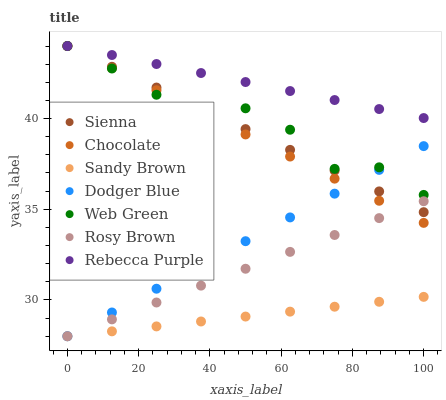Does Sandy Brown have the minimum area under the curve?
Answer yes or no. Yes. Does Rebecca Purple have the maximum area under the curve?
Answer yes or no. Yes. Does Web Green have the minimum area under the curve?
Answer yes or no. No. Does Web Green have the maximum area under the curve?
Answer yes or no. No. Is Rosy Brown the smoothest?
Answer yes or no. Yes. Is Web Green the roughest?
Answer yes or no. Yes. Is Chocolate the smoothest?
Answer yes or no. No. Is Chocolate the roughest?
Answer yes or no. No. Does Rosy Brown have the lowest value?
Answer yes or no. Yes. Does Web Green have the lowest value?
Answer yes or no. No. Does Rebecca Purple have the highest value?
Answer yes or no. Yes. Does Dodger Blue have the highest value?
Answer yes or no. No. Is Dodger Blue less than Rebecca Purple?
Answer yes or no. Yes. Is Chocolate greater than Sandy Brown?
Answer yes or no. Yes. Does Web Green intersect Dodger Blue?
Answer yes or no. Yes. Is Web Green less than Dodger Blue?
Answer yes or no. No. Is Web Green greater than Dodger Blue?
Answer yes or no. No. Does Dodger Blue intersect Rebecca Purple?
Answer yes or no. No. 